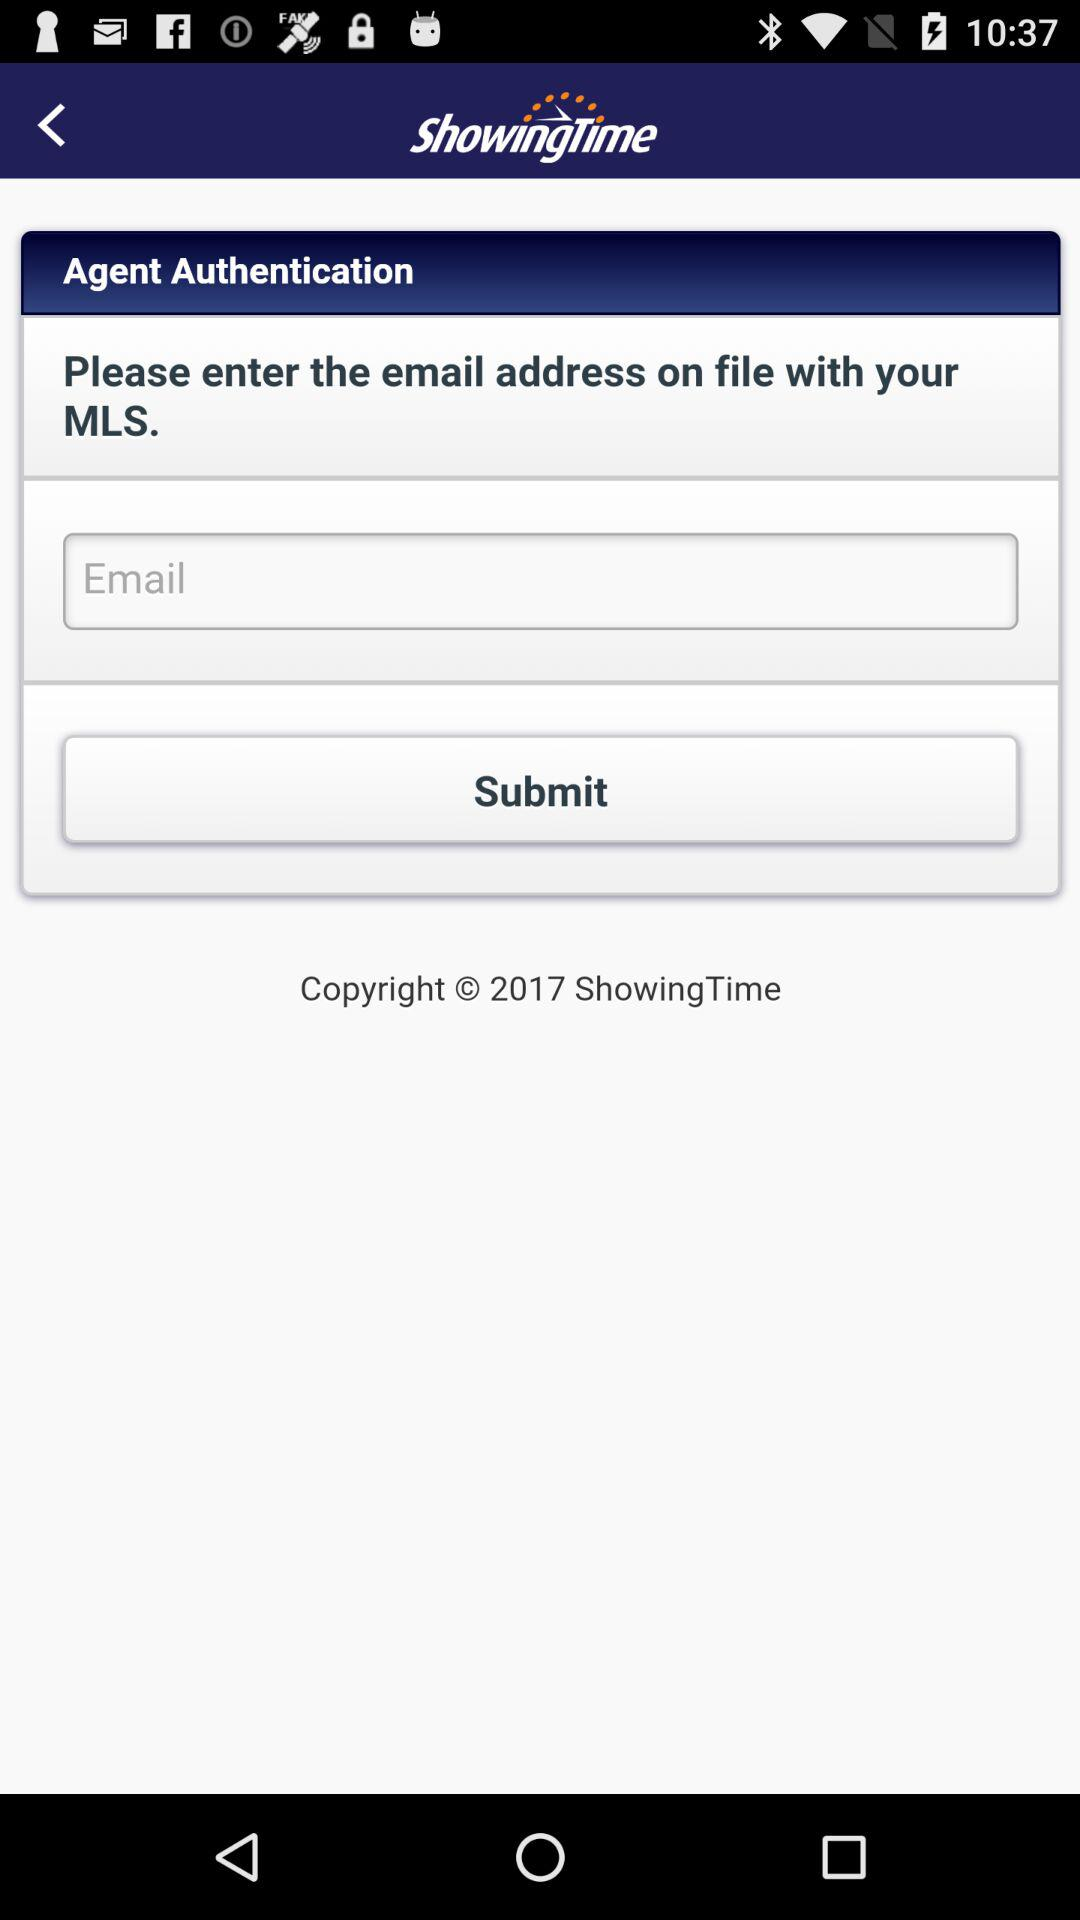What is the application name? The application name is "ShowingTime". 